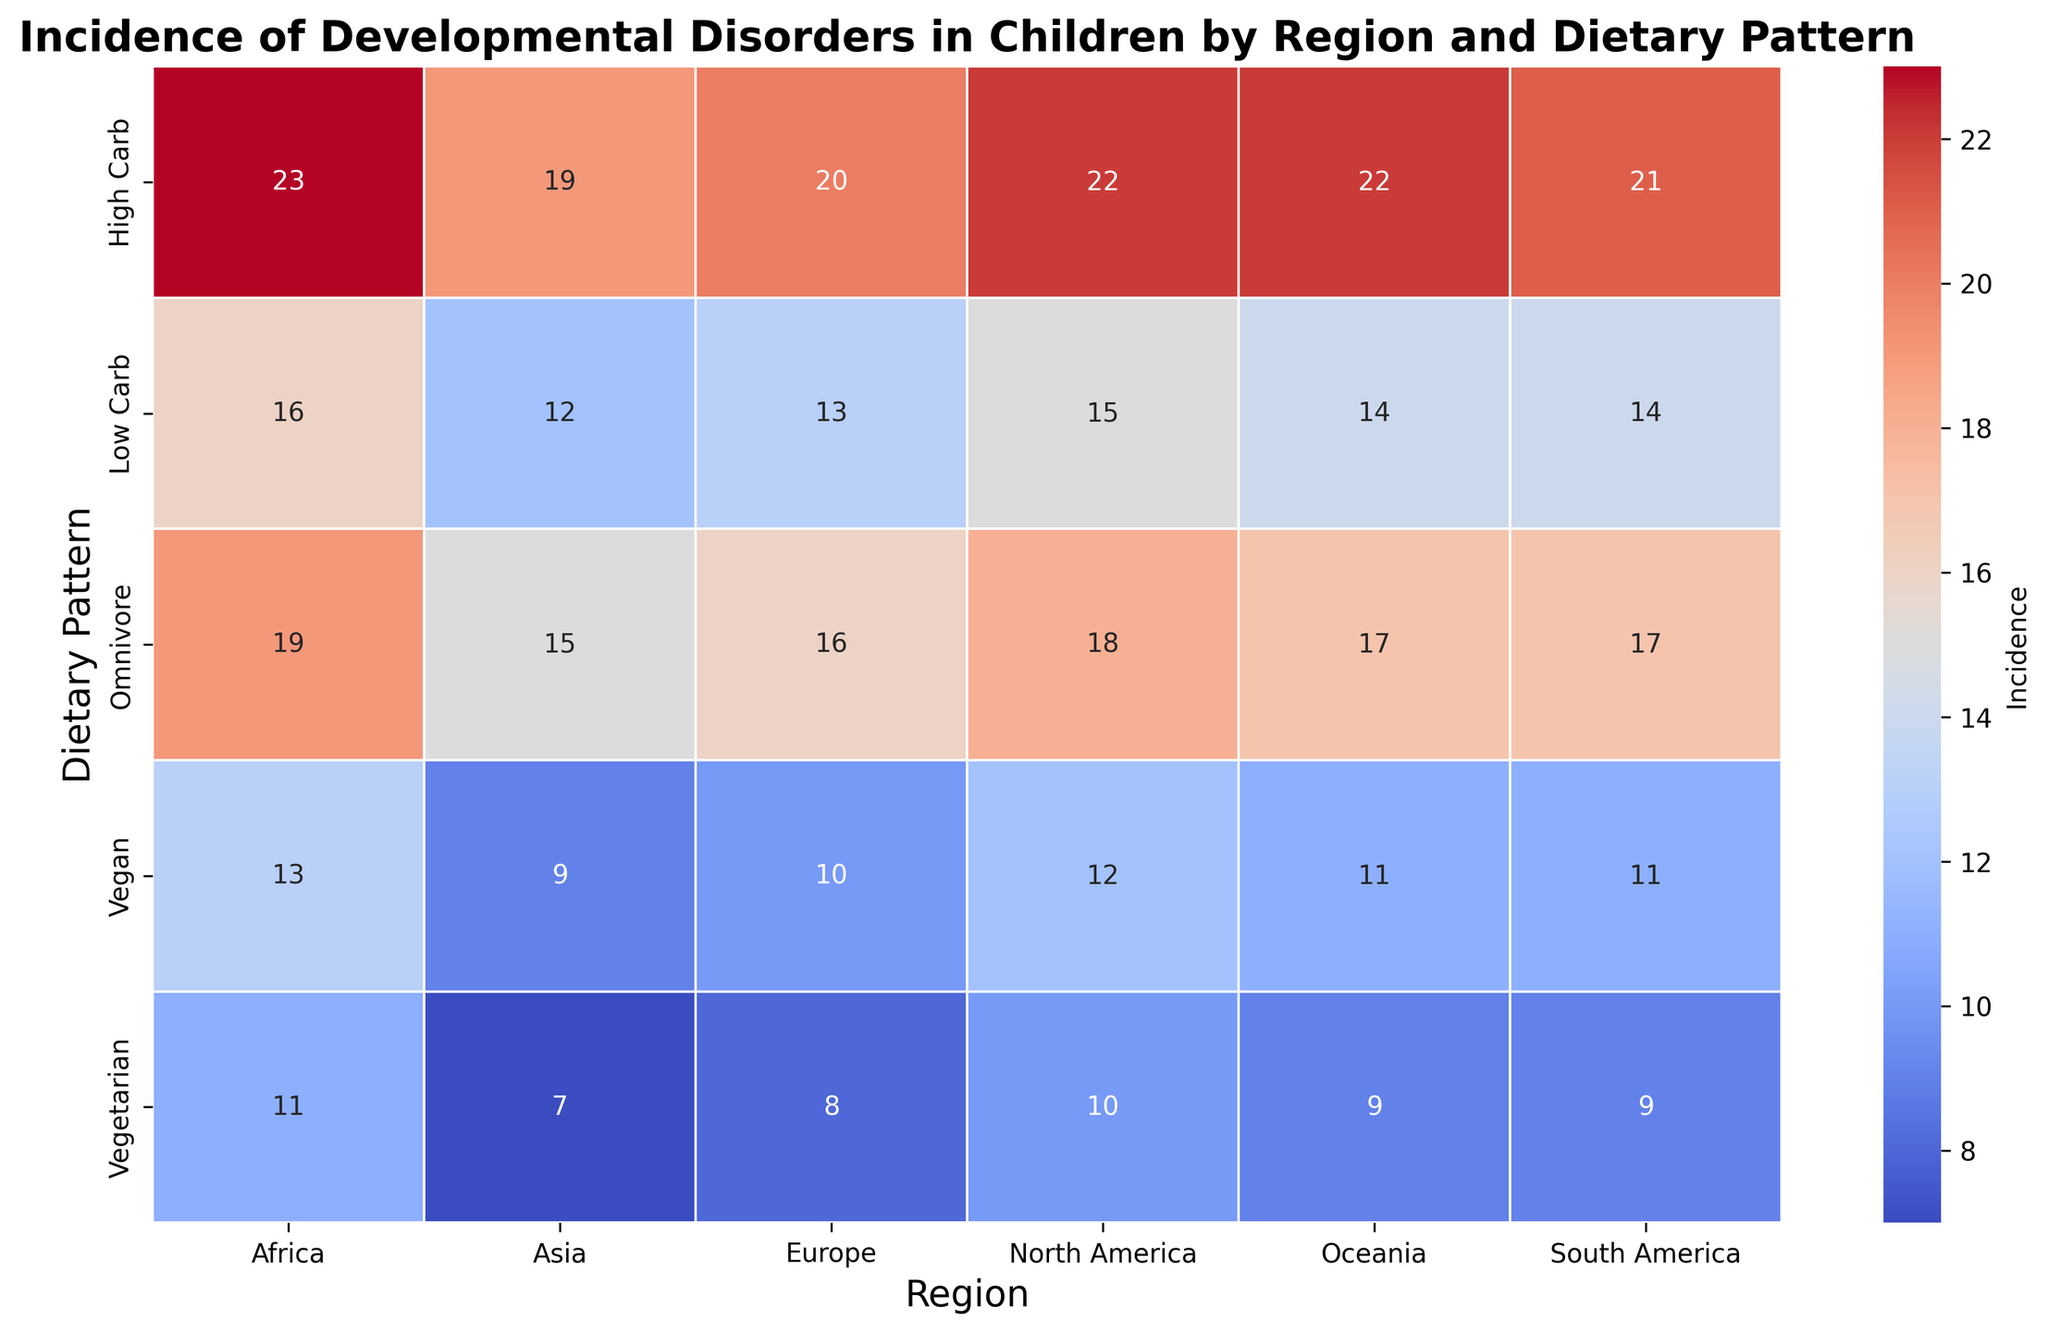Which region has the highest incidence of developmental disorders with a High Carb dietary pattern? Look at the 'High Carb' row and identify the cell with the darkest color, representing the highest incidence. The region corresponding to this cell is Africa, with an incidence of 23.
Answer: Africa Which dietary pattern has the lowest incidence of developmental disorders in Europe? Observe the 'Europe' column and find the cell with the lightest color, indicating the lowest incidence. The corresponding row is 'Vegetarian,' with an incidence of 8.
Answer: Vegetarian By how much does the incidence of developmental disorders in children with a Vegan diet in Africa exceed that in Asia? Look at the 'Vegan' row for both 'Africa' and 'Asia' columns. The incidence for Africa is 13 and for Asia is 9. Calculate the difference: 13 - 9 = 4.
Answer: 4 What is the average incidence of developmental disorders for children following an Omnivore diet across all regions? Sum the values from the 'Omnivore' row: 18 (North America) + 17 (South America) + 16 (Europe) + 15 (Asia) + 19 (Africa) + 17 (Oceania) = 102. Divide by the number of regions (6): 102 / 6 = 17.
Answer: 17 In which region do children on a Low Carb diet have a higher incidence of developmental disorders than those on a Vegetarian diet? Compare 'Low Carb' and 'Vegetarian' rows across all regions. North America (15 vs 10), South America (14 vs 9), Europe (13 vs 8), Asia (12 vs 7), Africa (16 vs 11), and Oceania (14 vs 9). In all regions, 'Low Carb' has a higher incidence than 'Vegetarian'.
Answer: All regions What is the total incidence of developmental disorders for children in North America and South America for a High Carb diet? Sum the incidences for High Carb diet in North America and South America: 22 + 21 = 43.
Answer: 43 Which dietary pattern shows the most consistent incidence of developmental disorders across all regions? Look for the dietary pattern with the least variation in color intensity across columns. Both 'Vegetarian' and 'Vegan' appear consistent, but 'Vegan' has slightly more variation. Therefore, 'Vegetarian' is the most consistent.
Answer: Vegetarian If the incidence of developmental disorders for a Vegan diet in Oceania increases by 2, how does it compare to the incidence for the same diet in North America? Initially, 'Vegan' in Oceania is 11. If it increases by 2, the new value is 11 + 2 = 13. Compare this to North America's 'Vegan' value of 12. Since 13 > 12, Oceania's incidence now exceeds North America's.
Answer: Higher 